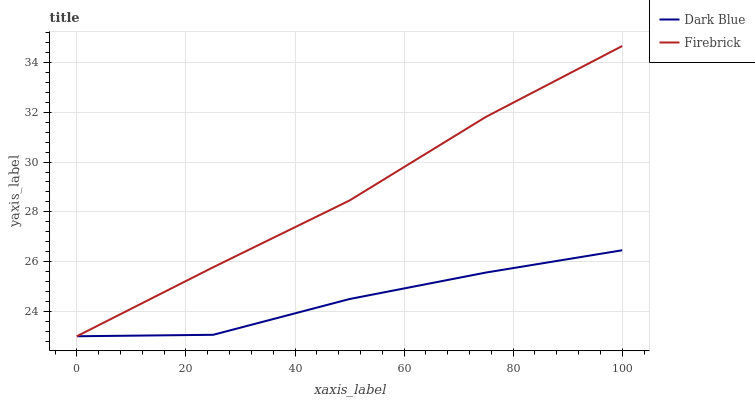Does Dark Blue have the minimum area under the curve?
Answer yes or no. Yes. Does Firebrick have the maximum area under the curve?
Answer yes or no. Yes. Does Firebrick have the minimum area under the curve?
Answer yes or no. No. Is Firebrick the smoothest?
Answer yes or no. Yes. Is Dark Blue the roughest?
Answer yes or no. Yes. Is Firebrick the roughest?
Answer yes or no. No. Does Dark Blue have the lowest value?
Answer yes or no. Yes. Does Firebrick have the highest value?
Answer yes or no. Yes. Does Firebrick intersect Dark Blue?
Answer yes or no. Yes. Is Firebrick less than Dark Blue?
Answer yes or no. No. Is Firebrick greater than Dark Blue?
Answer yes or no. No. 